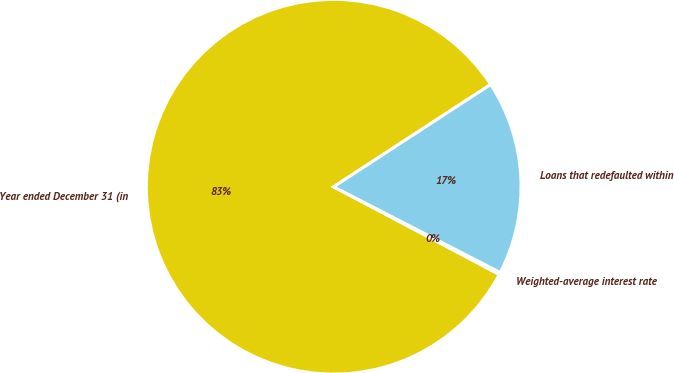Convert chart. <chart><loc_0><loc_0><loc_500><loc_500><pie_chart><fcel>Year ended December 31 (in<fcel>Weighted-average interest rate<fcel>Loans that redefaulted within<nl><fcel>83.06%<fcel>0.18%<fcel>16.76%<nl></chart> 